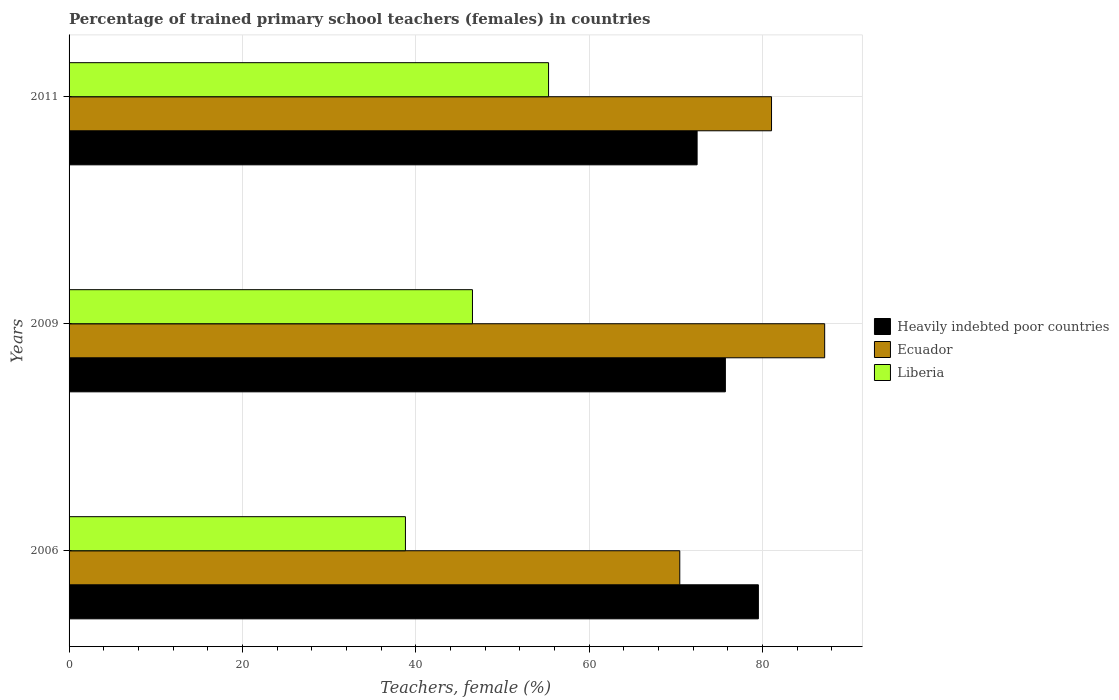How many groups of bars are there?
Keep it short and to the point. 3. How many bars are there on the 1st tick from the bottom?
Your answer should be very brief. 3. In how many cases, is the number of bars for a given year not equal to the number of legend labels?
Give a very brief answer. 0. What is the percentage of trained primary school teachers (females) in Heavily indebted poor countries in 2011?
Give a very brief answer. 72.46. Across all years, what is the maximum percentage of trained primary school teachers (females) in Heavily indebted poor countries?
Your answer should be very brief. 79.53. Across all years, what is the minimum percentage of trained primary school teachers (females) in Heavily indebted poor countries?
Your answer should be compact. 72.46. In which year was the percentage of trained primary school teachers (females) in Ecuador minimum?
Give a very brief answer. 2006. What is the total percentage of trained primary school teachers (females) in Heavily indebted poor countries in the graph?
Provide a short and direct response. 227.72. What is the difference between the percentage of trained primary school teachers (females) in Liberia in 2006 and that in 2009?
Give a very brief answer. -7.73. What is the difference between the percentage of trained primary school teachers (females) in Heavily indebted poor countries in 2006 and the percentage of trained primary school teachers (females) in Ecuador in 2009?
Keep it short and to the point. -7.65. What is the average percentage of trained primary school teachers (females) in Ecuador per year?
Your response must be concise. 79.57. In the year 2011, what is the difference between the percentage of trained primary school teachers (females) in Liberia and percentage of trained primary school teachers (females) in Ecuador?
Your answer should be very brief. -25.73. In how many years, is the percentage of trained primary school teachers (females) in Liberia greater than 20 %?
Provide a short and direct response. 3. What is the ratio of the percentage of trained primary school teachers (females) in Liberia in 2009 to that in 2011?
Your answer should be very brief. 0.84. What is the difference between the highest and the second highest percentage of trained primary school teachers (females) in Heavily indebted poor countries?
Ensure brevity in your answer.  3.81. What is the difference between the highest and the lowest percentage of trained primary school teachers (females) in Liberia?
Give a very brief answer. 16.51. What does the 2nd bar from the top in 2011 represents?
Give a very brief answer. Ecuador. What does the 3rd bar from the bottom in 2009 represents?
Offer a terse response. Liberia. Is it the case that in every year, the sum of the percentage of trained primary school teachers (females) in Liberia and percentage of trained primary school teachers (females) in Ecuador is greater than the percentage of trained primary school teachers (females) in Heavily indebted poor countries?
Give a very brief answer. Yes. How many bars are there?
Offer a terse response. 9. Are all the bars in the graph horizontal?
Give a very brief answer. Yes. How many years are there in the graph?
Your answer should be very brief. 3. Does the graph contain grids?
Offer a terse response. Yes. Where does the legend appear in the graph?
Provide a short and direct response. Center right. What is the title of the graph?
Provide a short and direct response. Percentage of trained primary school teachers (females) in countries. What is the label or title of the X-axis?
Keep it short and to the point. Teachers, female (%). What is the label or title of the Y-axis?
Ensure brevity in your answer.  Years. What is the Teachers, female (%) of Heavily indebted poor countries in 2006?
Offer a very short reply. 79.53. What is the Teachers, female (%) in Ecuador in 2006?
Offer a very short reply. 70.46. What is the Teachers, female (%) of Liberia in 2006?
Offer a very short reply. 38.81. What is the Teachers, female (%) of Heavily indebted poor countries in 2009?
Ensure brevity in your answer.  75.72. What is the Teachers, female (%) in Ecuador in 2009?
Your answer should be very brief. 87.18. What is the Teachers, female (%) of Liberia in 2009?
Your response must be concise. 46.54. What is the Teachers, female (%) of Heavily indebted poor countries in 2011?
Your answer should be compact. 72.46. What is the Teachers, female (%) of Ecuador in 2011?
Provide a succinct answer. 81.05. What is the Teachers, female (%) in Liberia in 2011?
Your response must be concise. 55.32. Across all years, what is the maximum Teachers, female (%) of Heavily indebted poor countries?
Ensure brevity in your answer.  79.53. Across all years, what is the maximum Teachers, female (%) in Ecuador?
Give a very brief answer. 87.18. Across all years, what is the maximum Teachers, female (%) in Liberia?
Provide a succinct answer. 55.32. Across all years, what is the minimum Teachers, female (%) of Heavily indebted poor countries?
Make the answer very short. 72.46. Across all years, what is the minimum Teachers, female (%) of Ecuador?
Give a very brief answer. 70.46. Across all years, what is the minimum Teachers, female (%) in Liberia?
Your answer should be compact. 38.81. What is the total Teachers, female (%) of Heavily indebted poor countries in the graph?
Give a very brief answer. 227.72. What is the total Teachers, female (%) in Ecuador in the graph?
Your answer should be compact. 238.7. What is the total Teachers, female (%) of Liberia in the graph?
Your answer should be compact. 140.68. What is the difference between the Teachers, female (%) of Heavily indebted poor countries in 2006 and that in 2009?
Ensure brevity in your answer.  3.81. What is the difference between the Teachers, female (%) of Ecuador in 2006 and that in 2009?
Keep it short and to the point. -16.72. What is the difference between the Teachers, female (%) of Liberia in 2006 and that in 2009?
Provide a short and direct response. -7.73. What is the difference between the Teachers, female (%) of Heavily indebted poor countries in 2006 and that in 2011?
Your answer should be very brief. 7.07. What is the difference between the Teachers, female (%) of Ecuador in 2006 and that in 2011?
Provide a succinct answer. -10.59. What is the difference between the Teachers, female (%) in Liberia in 2006 and that in 2011?
Ensure brevity in your answer.  -16.51. What is the difference between the Teachers, female (%) of Heavily indebted poor countries in 2009 and that in 2011?
Your answer should be very brief. 3.26. What is the difference between the Teachers, female (%) of Ecuador in 2009 and that in 2011?
Ensure brevity in your answer.  6.13. What is the difference between the Teachers, female (%) in Liberia in 2009 and that in 2011?
Provide a short and direct response. -8.78. What is the difference between the Teachers, female (%) of Heavily indebted poor countries in 2006 and the Teachers, female (%) of Ecuador in 2009?
Offer a terse response. -7.65. What is the difference between the Teachers, female (%) in Heavily indebted poor countries in 2006 and the Teachers, female (%) in Liberia in 2009?
Offer a very short reply. 32.99. What is the difference between the Teachers, female (%) of Ecuador in 2006 and the Teachers, female (%) of Liberia in 2009?
Your answer should be very brief. 23.92. What is the difference between the Teachers, female (%) of Heavily indebted poor countries in 2006 and the Teachers, female (%) of Ecuador in 2011?
Provide a short and direct response. -1.52. What is the difference between the Teachers, female (%) of Heavily indebted poor countries in 2006 and the Teachers, female (%) of Liberia in 2011?
Your answer should be very brief. 24.21. What is the difference between the Teachers, female (%) in Ecuador in 2006 and the Teachers, female (%) in Liberia in 2011?
Keep it short and to the point. 15.14. What is the difference between the Teachers, female (%) in Heavily indebted poor countries in 2009 and the Teachers, female (%) in Ecuador in 2011?
Make the answer very short. -5.33. What is the difference between the Teachers, female (%) of Heavily indebted poor countries in 2009 and the Teachers, female (%) of Liberia in 2011?
Ensure brevity in your answer.  20.4. What is the difference between the Teachers, female (%) in Ecuador in 2009 and the Teachers, female (%) in Liberia in 2011?
Your response must be concise. 31.86. What is the average Teachers, female (%) in Heavily indebted poor countries per year?
Provide a succinct answer. 75.91. What is the average Teachers, female (%) in Ecuador per year?
Provide a succinct answer. 79.57. What is the average Teachers, female (%) in Liberia per year?
Give a very brief answer. 46.89. In the year 2006, what is the difference between the Teachers, female (%) in Heavily indebted poor countries and Teachers, female (%) in Ecuador?
Keep it short and to the point. 9.07. In the year 2006, what is the difference between the Teachers, female (%) in Heavily indebted poor countries and Teachers, female (%) in Liberia?
Make the answer very short. 40.72. In the year 2006, what is the difference between the Teachers, female (%) in Ecuador and Teachers, female (%) in Liberia?
Provide a short and direct response. 31.65. In the year 2009, what is the difference between the Teachers, female (%) in Heavily indebted poor countries and Teachers, female (%) in Ecuador?
Offer a very short reply. -11.46. In the year 2009, what is the difference between the Teachers, female (%) of Heavily indebted poor countries and Teachers, female (%) of Liberia?
Keep it short and to the point. 29.18. In the year 2009, what is the difference between the Teachers, female (%) of Ecuador and Teachers, female (%) of Liberia?
Offer a terse response. 40.64. In the year 2011, what is the difference between the Teachers, female (%) in Heavily indebted poor countries and Teachers, female (%) in Ecuador?
Make the answer very short. -8.59. In the year 2011, what is the difference between the Teachers, female (%) in Heavily indebted poor countries and Teachers, female (%) in Liberia?
Offer a terse response. 17.14. In the year 2011, what is the difference between the Teachers, female (%) of Ecuador and Teachers, female (%) of Liberia?
Your answer should be compact. 25.73. What is the ratio of the Teachers, female (%) of Heavily indebted poor countries in 2006 to that in 2009?
Ensure brevity in your answer.  1.05. What is the ratio of the Teachers, female (%) in Ecuador in 2006 to that in 2009?
Your answer should be compact. 0.81. What is the ratio of the Teachers, female (%) in Liberia in 2006 to that in 2009?
Your response must be concise. 0.83. What is the ratio of the Teachers, female (%) of Heavily indebted poor countries in 2006 to that in 2011?
Keep it short and to the point. 1.1. What is the ratio of the Teachers, female (%) in Ecuador in 2006 to that in 2011?
Your response must be concise. 0.87. What is the ratio of the Teachers, female (%) in Liberia in 2006 to that in 2011?
Your response must be concise. 0.7. What is the ratio of the Teachers, female (%) of Heavily indebted poor countries in 2009 to that in 2011?
Make the answer very short. 1.04. What is the ratio of the Teachers, female (%) in Ecuador in 2009 to that in 2011?
Provide a short and direct response. 1.08. What is the ratio of the Teachers, female (%) of Liberia in 2009 to that in 2011?
Make the answer very short. 0.84. What is the difference between the highest and the second highest Teachers, female (%) of Heavily indebted poor countries?
Offer a terse response. 3.81. What is the difference between the highest and the second highest Teachers, female (%) in Ecuador?
Make the answer very short. 6.13. What is the difference between the highest and the second highest Teachers, female (%) of Liberia?
Give a very brief answer. 8.78. What is the difference between the highest and the lowest Teachers, female (%) in Heavily indebted poor countries?
Your answer should be very brief. 7.07. What is the difference between the highest and the lowest Teachers, female (%) of Ecuador?
Keep it short and to the point. 16.72. What is the difference between the highest and the lowest Teachers, female (%) of Liberia?
Your answer should be compact. 16.51. 